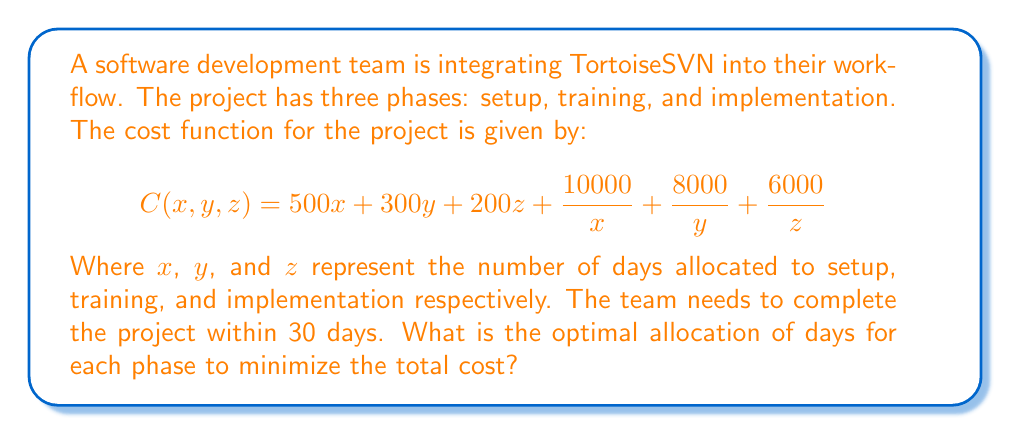Solve this math problem. To solve this optimization problem, we'll use the method of Lagrange multipliers:

1) First, we set up the Lagrangian function:
   $$L(x, y, z, \lambda) = 500x + 300y + 200z + \frac{10000}{x} + \frac{8000}{y} + \frac{6000}{z} + \lambda(x + y + z - 30)$$

2) Now, we take partial derivatives and set them equal to zero:
   $$\frac{\partial L}{\partial x} = 500 - \frac{10000}{x^2} + \lambda = 0$$
   $$\frac{\partial L}{\partial y} = 300 - \frac{8000}{y^2} + \lambda = 0$$
   $$\frac{\partial L}{\partial z} = 200 - \frac{6000}{z^2} + \lambda = 0$$
   $$\frac{\partial L}{\partial \lambda} = x + y + z - 30 = 0$$

3) From the first three equations:
   $$\frac{10000}{x^2} = 500 + \lambda$$
   $$\frac{8000}{y^2} = 300 + \lambda$$
   $$\frac{6000}{z^2} = 200 + \lambda$$

4) Dividing these equations:
   $$\frac{x^2}{y^2} = \frac{10000}{8000} \cdot \frac{300 + \lambda}{500 + \lambda} = \frac{5}{4} \cdot \frac{300 + \lambda}{500 + \lambda}$$
   $$\frac{y^2}{z^2} = \frac{8000}{6000} \cdot \frac{200 + \lambda}{300 + \lambda} = \frac{4}{3} \cdot \frac{200 + \lambda}{300 + \lambda}$$

5) As $\lambda$ approaches infinity, these ratios approach:
   $$\frac{x^2}{y^2} \approx \frac{5}{4} \text{ and } \frac{y^2}{z^2} \approx \frac{4}{3}$$

6) This gives us the ratios:
   $$x : y : z = \sqrt{5} : 2 : \sqrt{3}$$

7) Using the constraint $x + y + z = 30$, we can solve:
   $$\sqrt{5}k + 2k + \sqrt{3}k = 30$$
   $$k(\sqrt{5} + 2 + \sqrt{3}) = 30$$
   $$k = \frac{30}{\sqrt{5} + 2 + \sqrt{3}} \approx 5.085$$

8) Therefore:
   $$x \approx 5.085\sqrt{5} \approx 11.37$$
   $$y \approx 5.085 \cdot 2 \approx 10.17$$
   $$z \approx 5.085\sqrt{3} \approx 8.81$$

Rounding to the nearest whole number (as we can't have fractional days):
$x = 11$, $y = 10$, and $z = 9$
Answer: The optimal allocation is approximately 11 days for setup, 10 days for training, and 9 days for implementation. 